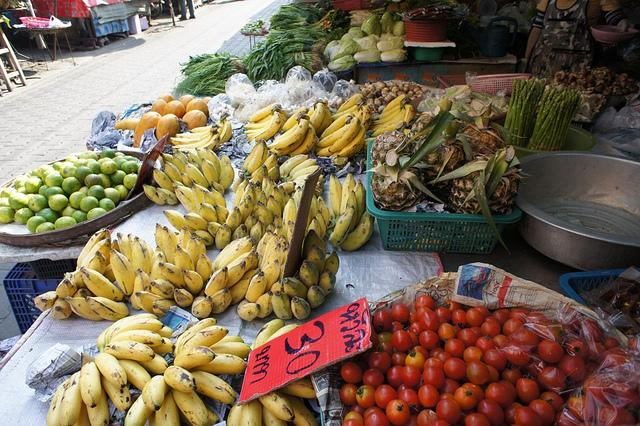What color are the sweet fruits?

Choices:
A) green
B) yellow
C) brown
D) red yellow 